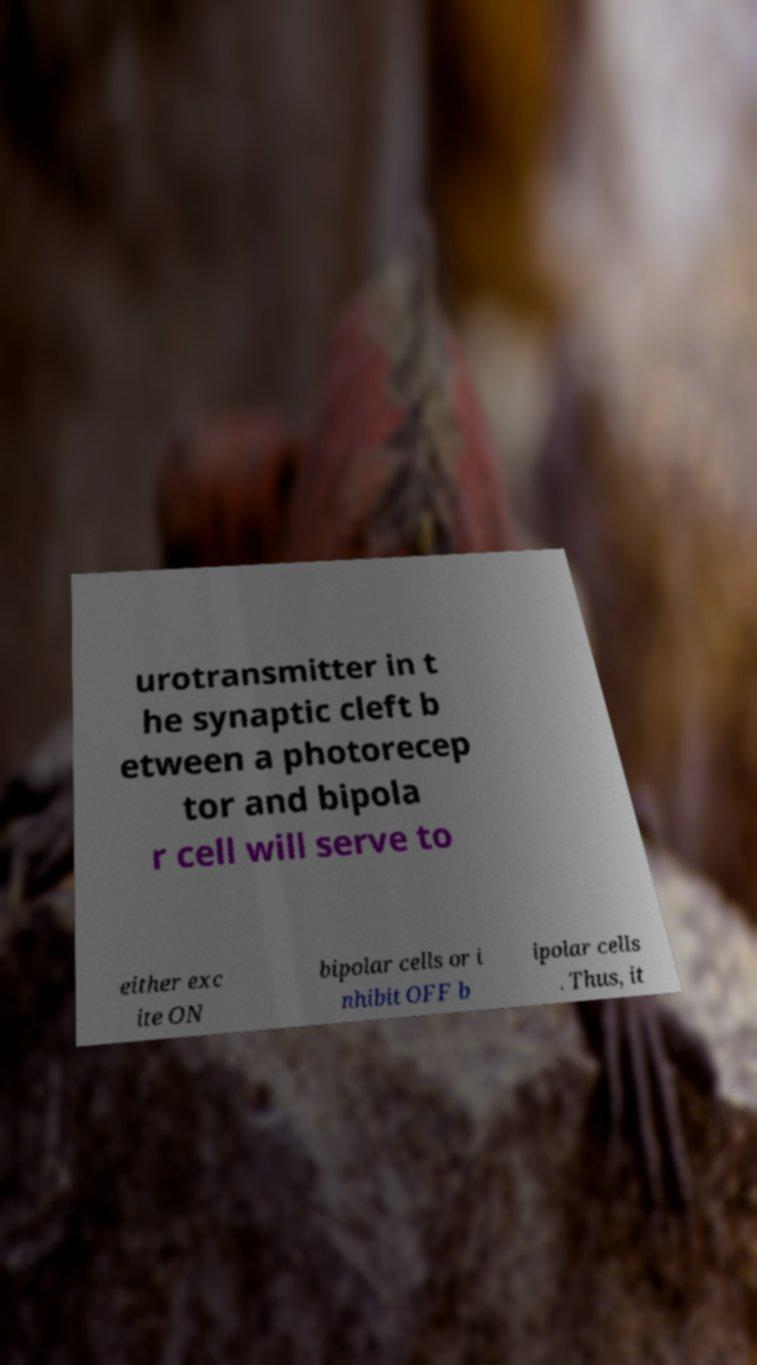What messages or text are displayed in this image? I need them in a readable, typed format. urotransmitter in t he synaptic cleft b etween a photorecep tor and bipola r cell will serve to either exc ite ON bipolar cells or i nhibit OFF b ipolar cells . Thus, it 